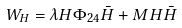Convert formula to latex. <formula><loc_0><loc_0><loc_500><loc_500>W _ { H } = \lambda H \Phi _ { 2 4 } \bar { H } + M H \bar { H }</formula> 